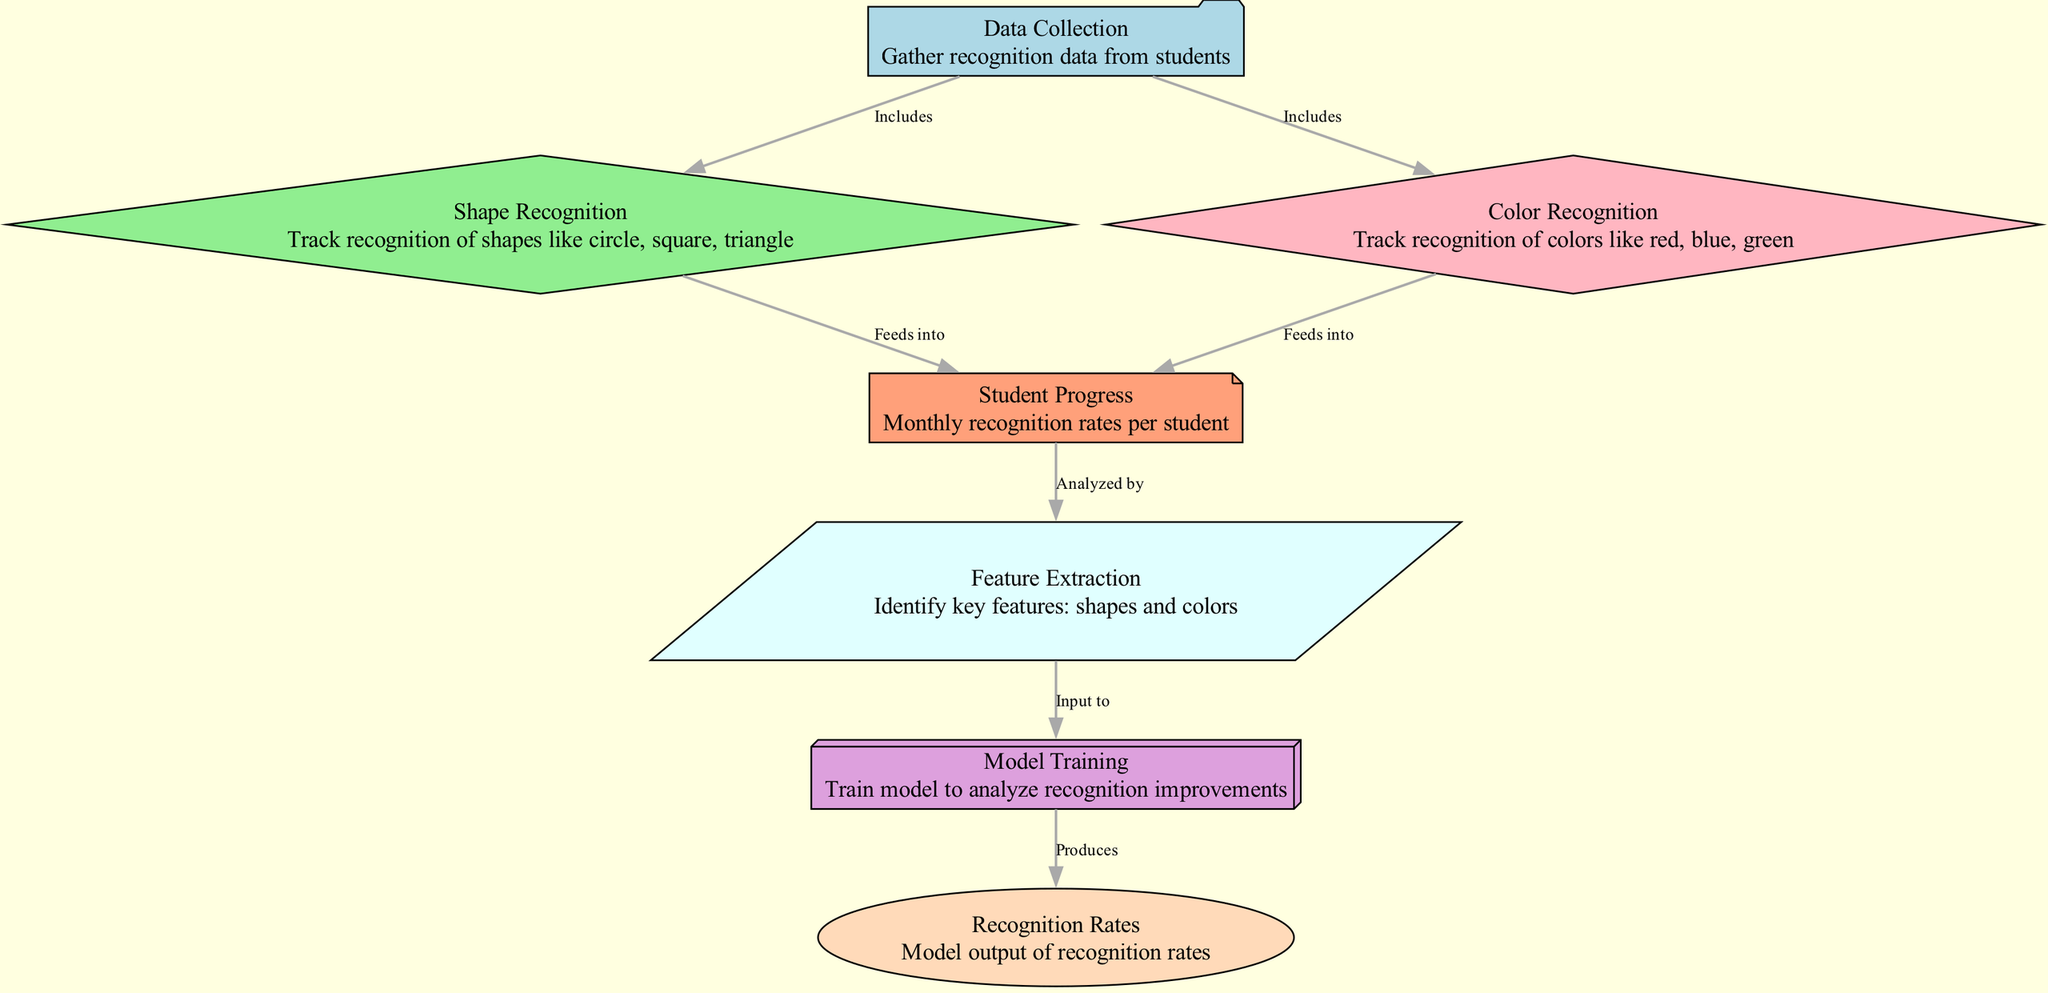What is the first step in the diagram? The first step in the diagram is "Data Collection." This node represents the initial stage where data on students' recognition is gathered.
Answer: Data Collection How many nodes are in the diagram? There are seven nodes in the diagram, each representing a key component of the machine learning process related to recognition of shapes and colors.
Answer: Seven What color represents the "Shape Recognition" node? The "Shape Recognition" node is represented by the color light green, indicating its function of tracking shape recognition.
Answer: Light green Which node produces the recognition rates? The "Model Training" node produces the recognition rates. It analyzes the data collected and is responsible for outputting the calculated recognition rates.
Answer: Model Training What is the relationship between "Color Recognition" and "Student Progress"? "Color Recognition" feeds into "Student Progress," meaning that the data collected about color recognition affects the overall assessment of students' progress in recognizing shapes and colors.
Answer: Feeds into What are the key features identified in the diagram? The key features identified are shapes and colors, as highlighted in the "Feature Extraction" node, which serves to identify these elements from the collected data.
Answer: Shapes and colors Which process analyzes monthly recognition rates? The "Student Progress" node analyzes the monthly recognition rates. It assesses how well each student is recognizing shapes and colors over time.
Answer: Student Progress How does "Feature Extraction" contribute to the model training? "Feature Extraction" provides the necessary input to the "Model Training" node, enabling the model to learn and improve its analysis of recognition rates based on the extracted features.
Answer: Input to What type of shapes and colors are being tracked in this diagram? The shapes are circle, square, and triangle, while the colors being tracked include red, blue, and green, as indicated in the "Shape Recognition" and "Color Recognition" nodes.
Answer: Circle, square, triangle; red, blue, green 